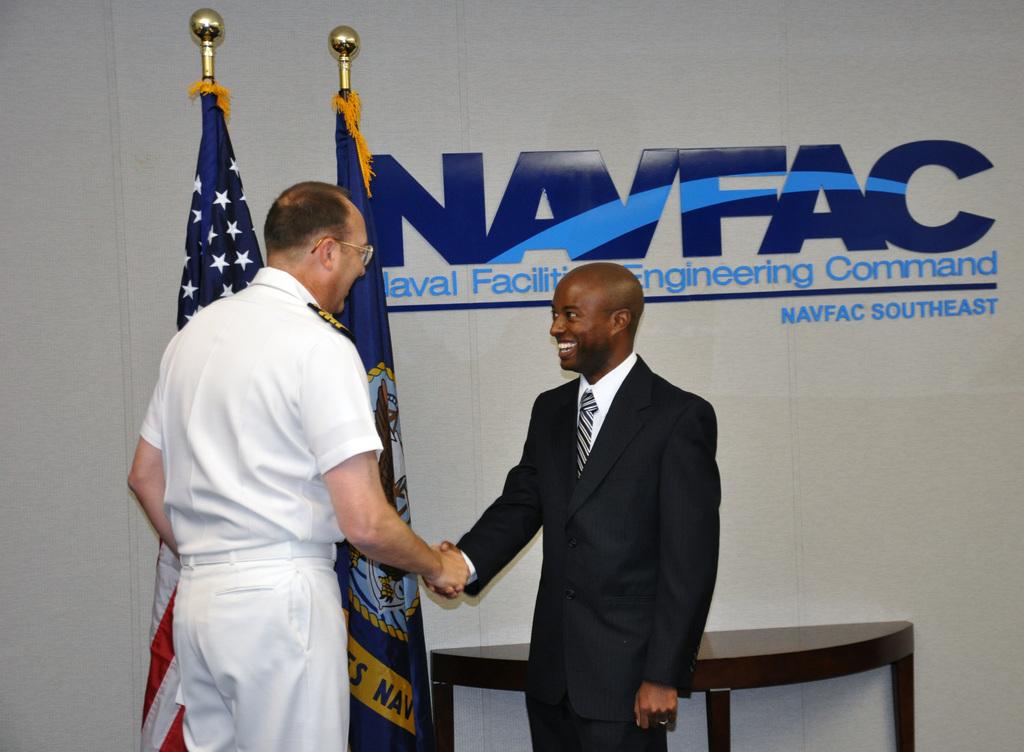What branch of the military is represented here?
Offer a very short reply. Navy. What command are they at?
Offer a terse response. Naval facility engineering command. 